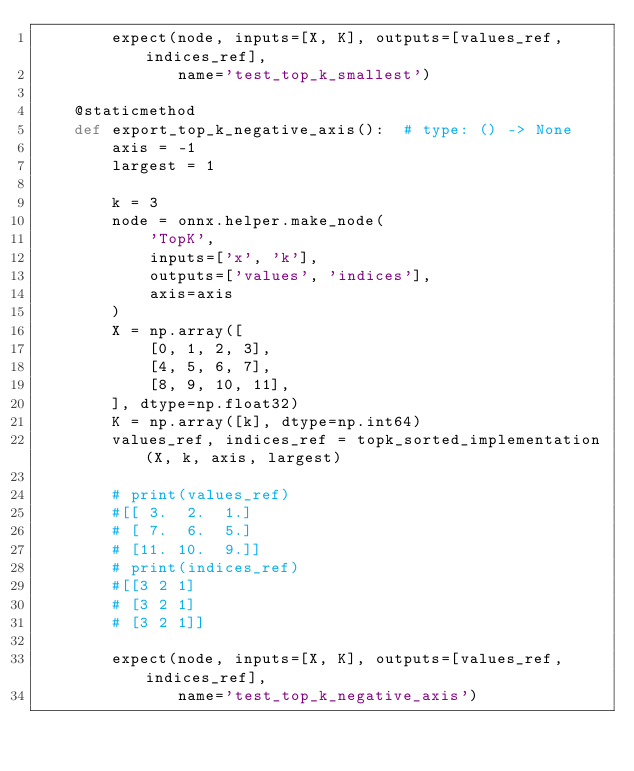<code> <loc_0><loc_0><loc_500><loc_500><_Python_>        expect(node, inputs=[X, K], outputs=[values_ref, indices_ref],
               name='test_top_k_smallest')

    @staticmethod
    def export_top_k_negative_axis():  # type: () -> None
        axis = -1
        largest = 1

        k = 3
        node = onnx.helper.make_node(
            'TopK',
            inputs=['x', 'k'],
            outputs=['values', 'indices'],
            axis=axis
        )
        X = np.array([
            [0, 1, 2, 3],
            [4, 5, 6, 7],
            [8, 9, 10, 11],
        ], dtype=np.float32)
        K = np.array([k], dtype=np.int64)
        values_ref, indices_ref = topk_sorted_implementation(X, k, axis, largest)

        # print(values_ref)
        #[[ 3.  2.  1.]
        # [ 7.  6.  5.]
        # [11. 10.  9.]]
        # print(indices_ref)
        #[[3 2 1]
        # [3 2 1]
        # [3 2 1]]

        expect(node, inputs=[X, K], outputs=[values_ref, indices_ref],
               name='test_top_k_negative_axis')
</code> 